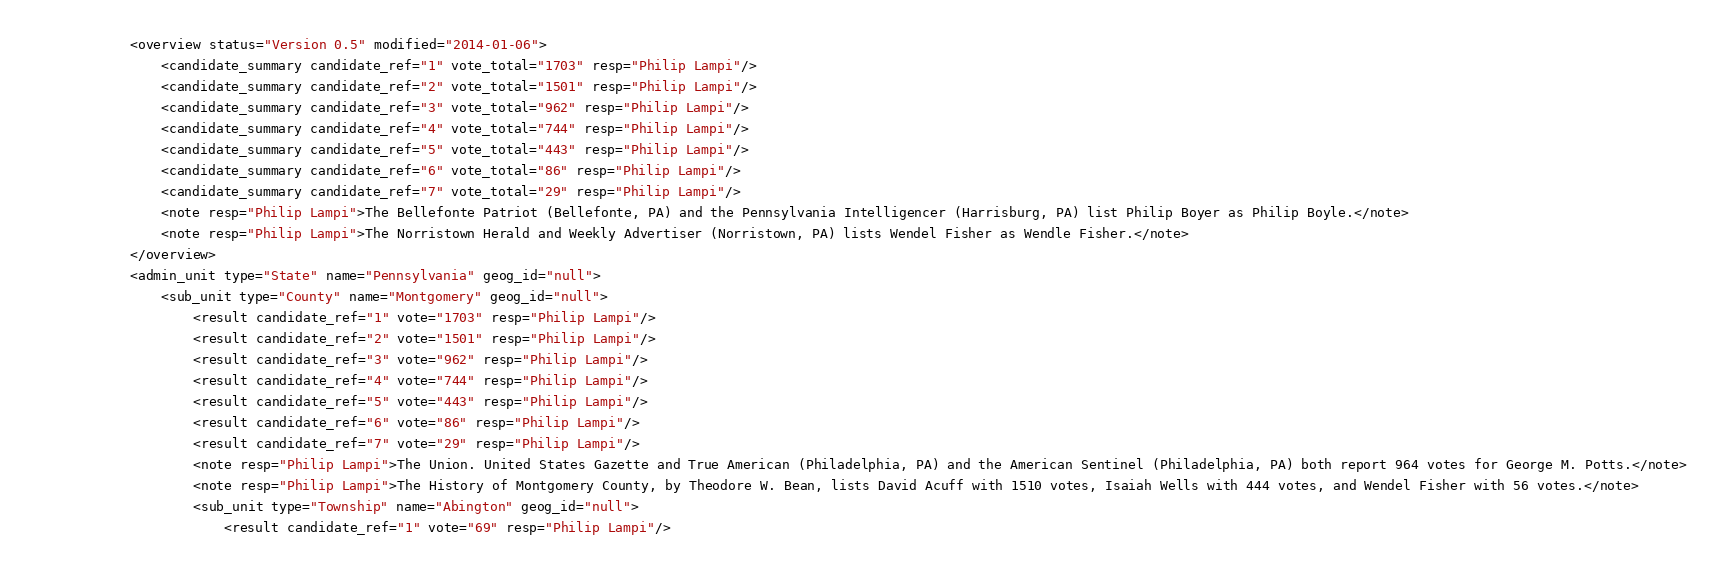<code> <loc_0><loc_0><loc_500><loc_500><_XML_>			<overview status="Version 0.5" modified="2014-01-06">
				<candidate_summary candidate_ref="1" vote_total="1703" resp="Philip Lampi"/>
				<candidate_summary candidate_ref="2" vote_total="1501" resp="Philip Lampi"/>
				<candidate_summary candidate_ref="3" vote_total="962" resp="Philip Lampi"/>
				<candidate_summary candidate_ref="4" vote_total="744" resp="Philip Lampi"/>
				<candidate_summary candidate_ref="5" vote_total="443" resp="Philip Lampi"/>
				<candidate_summary candidate_ref="6" vote_total="86" resp="Philip Lampi"/>
				<candidate_summary candidate_ref="7" vote_total="29" resp="Philip Lampi"/>
				<note resp="Philip Lampi">The Bellefonte Patriot (Bellefonte, PA) and the Pennsylvania Intelligencer (Harrisburg, PA) list Philip Boyer as Philip Boyle.</note>
				<note resp="Philip Lampi">The Norristown Herald and Weekly Advertiser (Norristown, PA) lists Wendel Fisher as Wendle Fisher.</note>
			</overview>
			<admin_unit type="State" name="Pennsylvania" geog_id="null">
				<sub_unit type="County" name="Montgomery" geog_id="null">
					<result candidate_ref="1" vote="1703" resp="Philip Lampi"/>
					<result candidate_ref="2" vote="1501" resp="Philip Lampi"/>
					<result candidate_ref="3" vote="962" resp="Philip Lampi"/>
					<result candidate_ref="4" vote="744" resp="Philip Lampi"/>
					<result candidate_ref="5" vote="443" resp="Philip Lampi"/>
					<result candidate_ref="6" vote="86" resp="Philip Lampi"/>
					<result candidate_ref="7" vote="29" resp="Philip Lampi"/>
					<note resp="Philip Lampi">The Union. United States Gazette and True American (Philadelphia, PA) and the American Sentinel (Philadelphia, PA) both report 964 votes for George M. Potts.</note>
					<note resp="Philip Lampi">The History of Montgomery County, by Theodore W. Bean, lists David Acuff with 1510 votes, Isaiah Wells with 444 votes, and Wendel Fisher with 56 votes.</note>
					<sub_unit type="Township" name="Abington" geog_id="null">
						<result candidate_ref="1" vote="69" resp="Philip Lampi"/></code> 